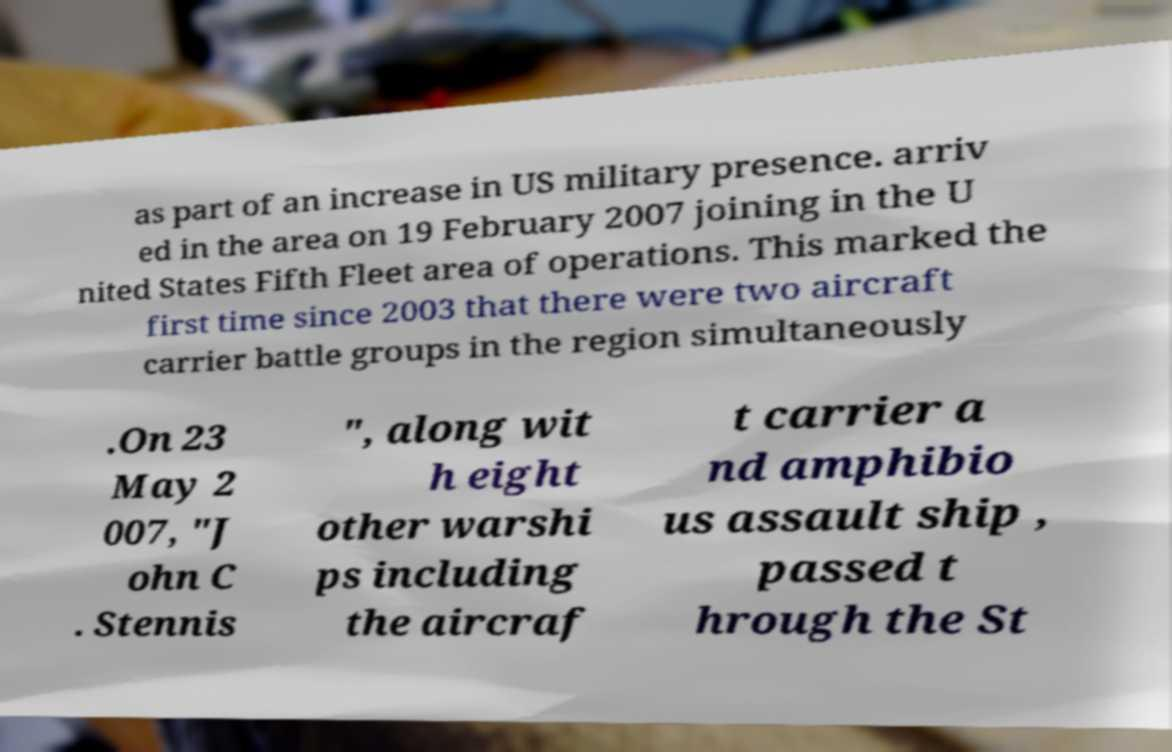There's text embedded in this image that I need extracted. Can you transcribe it verbatim? as part of an increase in US military presence. arriv ed in the area on 19 February 2007 joining in the U nited States Fifth Fleet area of operations. This marked the first time since 2003 that there were two aircraft carrier battle groups in the region simultaneously .On 23 May 2 007, "J ohn C . Stennis ", along wit h eight other warshi ps including the aircraf t carrier a nd amphibio us assault ship , passed t hrough the St 